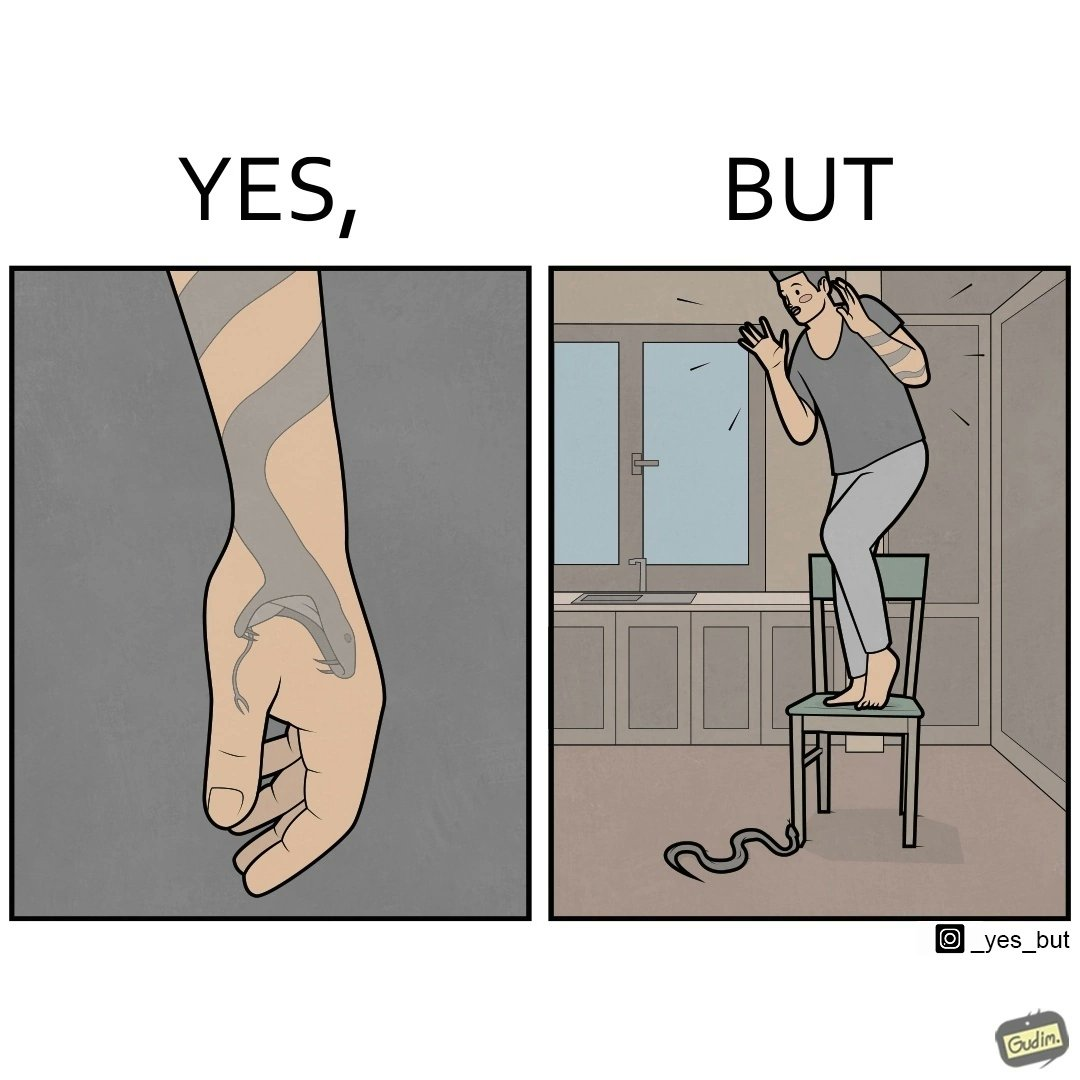Explain the humor or irony in this image. The image is ironic, because in the first image the tattoo of a snake on someone's hand may give us a hint about how powerful or brave the person can be who is having this tattoo but in the second image the person with same tattoo is seen frightened due to a snake in his house 